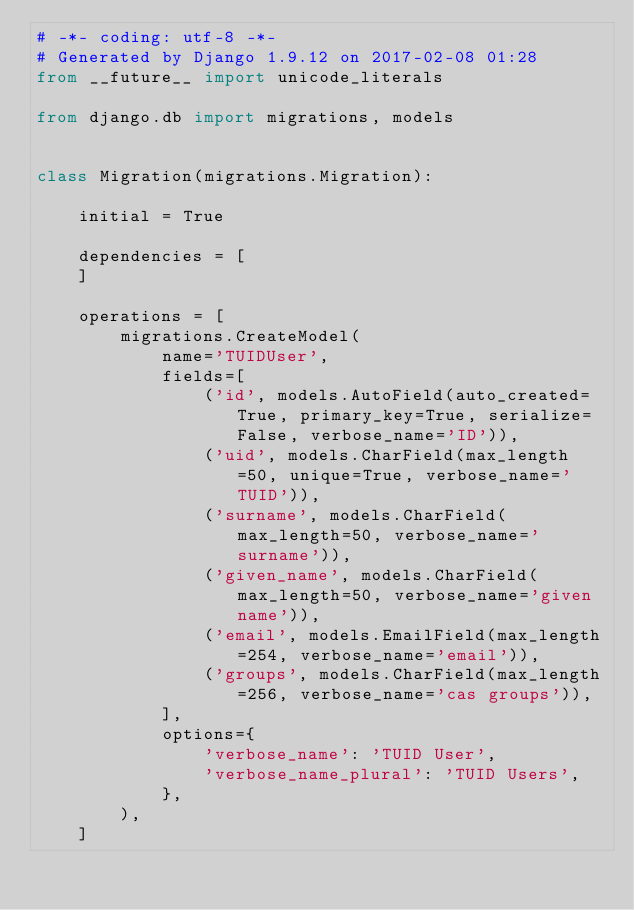Convert code to text. <code><loc_0><loc_0><loc_500><loc_500><_Python_># -*- coding: utf-8 -*-
# Generated by Django 1.9.12 on 2017-02-08 01:28
from __future__ import unicode_literals

from django.db import migrations, models


class Migration(migrations.Migration):

    initial = True

    dependencies = [
    ]

    operations = [
        migrations.CreateModel(
            name='TUIDUser',
            fields=[
                ('id', models.AutoField(auto_created=True, primary_key=True, serialize=False, verbose_name='ID')),
                ('uid', models.CharField(max_length=50, unique=True, verbose_name='TUID')),
                ('surname', models.CharField(max_length=50, verbose_name='surname')),
                ('given_name', models.CharField(max_length=50, verbose_name='given name')),
                ('email', models.EmailField(max_length=254, verbose_name='email')),
                ('groups', models.CharField(max_length=256, verbose_name='cas groups')),
            ],
            options={
                'verbose_name': 'TUID User',
                'verbose_name_plural': 'TUID Users',
            },
        ),
    ]
</code> 